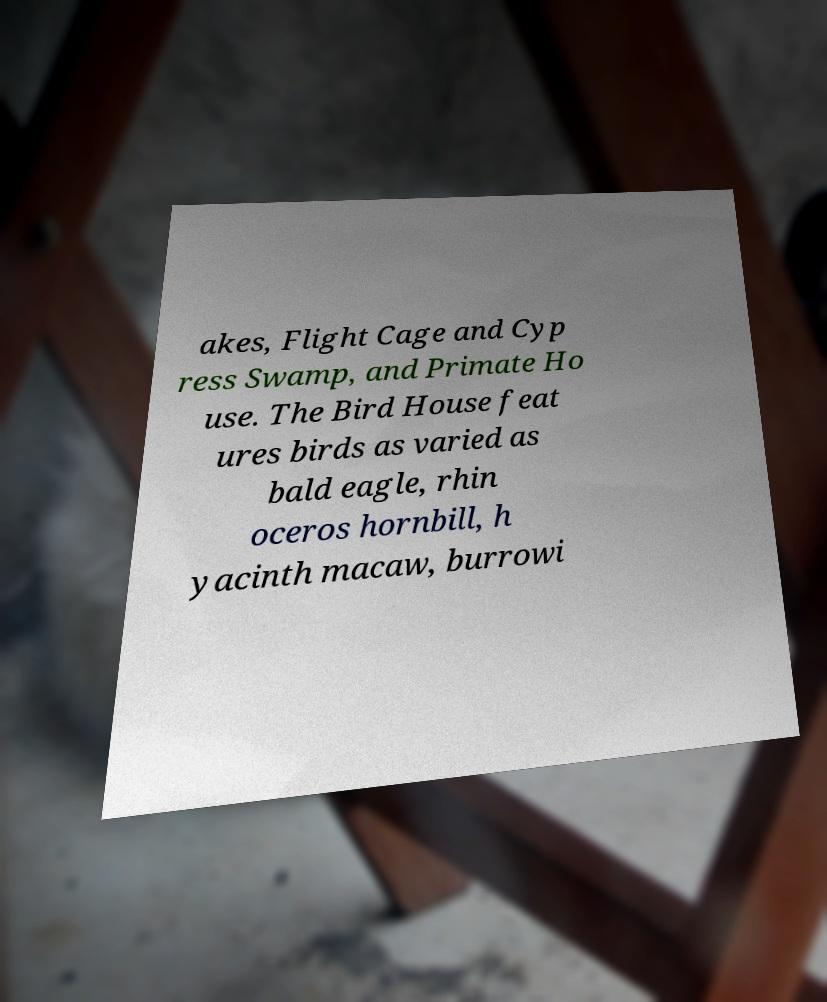For documentation purposes, I need the text within this image transcribed. Could you provide that? akes, Flight Cage and Cyp ress Swamp, and Primate Ho use. The Bird House feat ures birds as varied as bald eagle, rhin oceros hornbill, h yacinth macaw, burrowi 